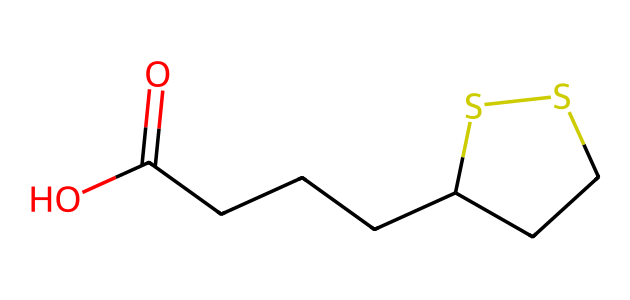How many carbon atoms are in alpha-lipoic acid? By examining the SMILES representation, we identify the number of carbon atoms present in the structure. The sequence contains multiple 'C' characters, and when counted, they sum up to the total carbon atoms. In this case, there are 6 carbon atoms.
Answer: 6 What functional group is represented by the "O=C(O)" part of the chemical? The "O=C(O)" indicates the presence of a carboxylic acid functional group. The 'C' is double-bonded to one 'O' (the carbonyl) and single-bonded to another 'O' (the hydroxyl group). This structure clearly indicates it is a carboxylic acid.
Answer: carboxylic acid What is the role of sulfur in alpha-lipoic acid? In the structure of alpha-lipoic acid, the sulfur atoms (S) play a crucial role in its antioxidant properties. The two sulfur atoms are involved in the formation of a disulfide bond that is essential for its functionality in various biological redox reactions.
Answer: antioxidant properties How many total hydrogen atoms are in this compound? To find the total hydrogen atoms, we consider the hydrogen attachment to each carbon and functional groups in the SMILES representation. Each carbon typically bonds with sufficient hydrogen atoms to fulfill its tetravalence. After systematically analyzing, we determine there are 10 hydrogen atoms present in total.
Answer: 10 Is alpha-lipoic acid a solid or liquid at room temperature? Based on typical properties and molecular structure analysis of alpha-lipoic acid, its melting point indicates that it exists as a solid at room temperature. The presence of multiple carbon chains and functional groups contributes to this phase.
Answer: solid 